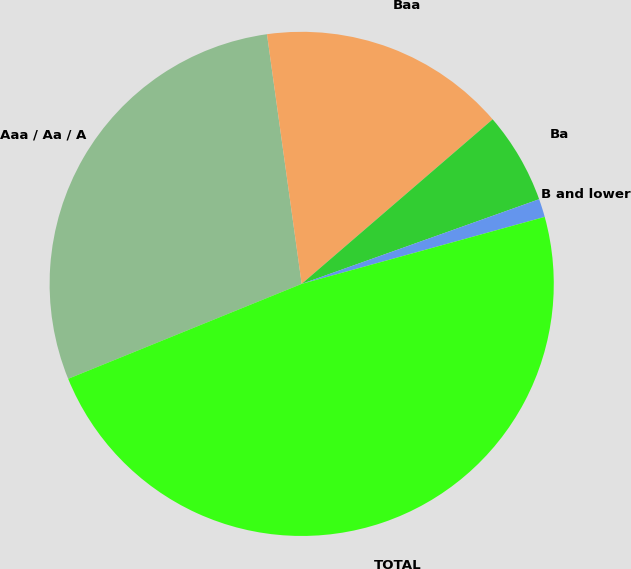<chart> <loc_0><loc_0><loc_500><loc_500><pie_chart><fcel>Aaa / Aa / A<fcel>Baa<fcel>Ba<fcel>B and lower<fcel>TOTAL<nl><fcel>28.95%<fcel>15.88%<fcel>5.87%<fcel>1.17%<fcel>48.14%<nl></chart> 